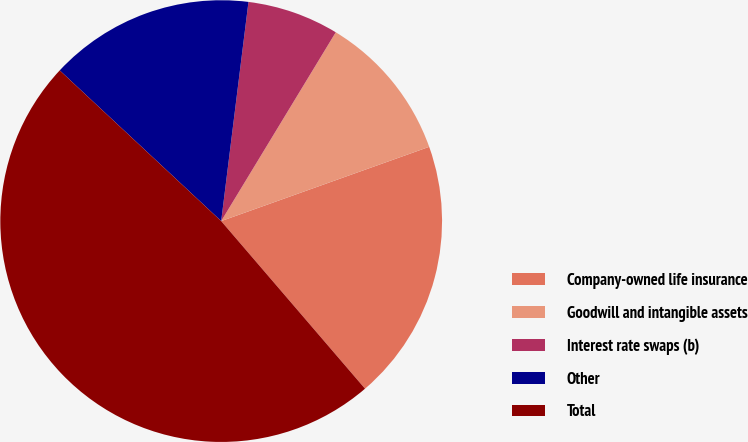Convert chart to OTSL. <chart><loc_0><loc_0><loc_500><loc_500><pie_chart><fcel>Company-owned life insurance<fcel>Goodwill and intangible assets<fcel>Interest rate swaps (b)<fcel>Other<fcel>Total<nl><fcel>19.17%<fcel>10.86%<fcel>6.71%<fcel>15.02%<fcel>48.24%<nl></chart> 